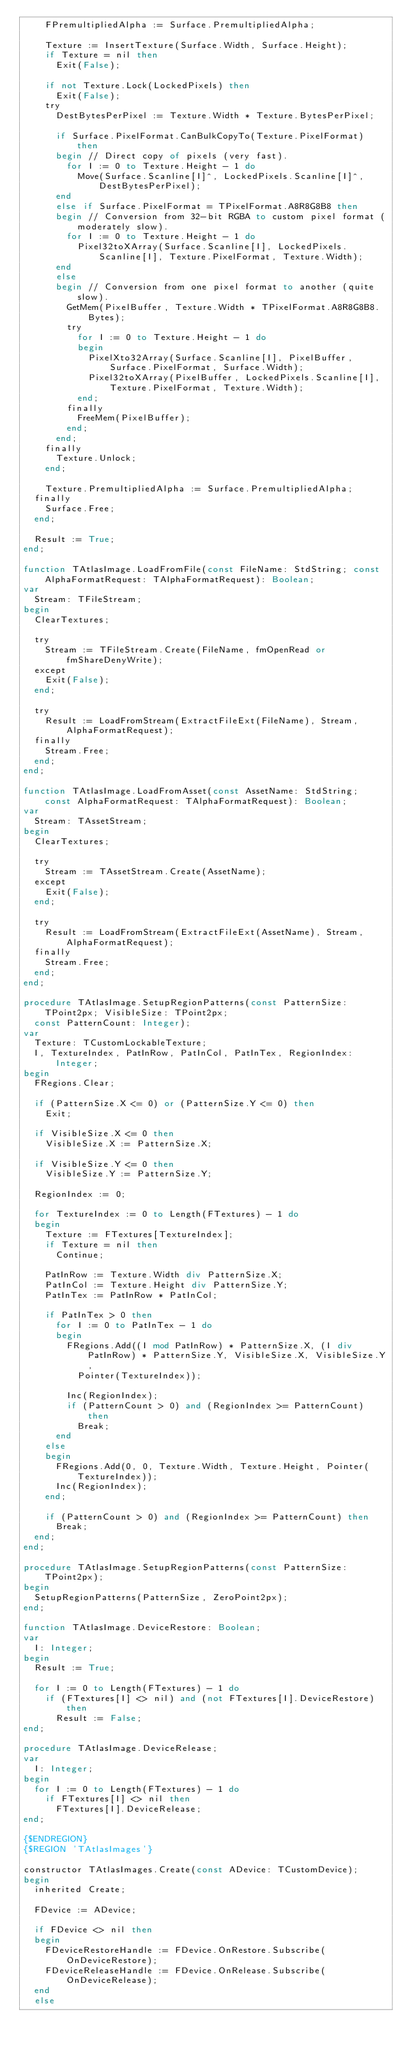Convert code to text. <code><loc_0><loc_0><loc_500><loc_500><_Pascal_>    FPremultipliedAlpha := Surface.PremultipliedAlpha;

    Texture := InsertTexture(Surface.Width, Surface.Height);
    if Texture = nil then
      Exit(False);

    if not Texture.Lock(LockedPixels) then
      Exit(False);
    try
      DestBytesPerPixel := Texture.Width * Texture.BytesPerPixel;

      if Surface.PixelFormat.CanBulkCopyTo(Texture.PixelFormat) then
      begin // Direct copy of pixels (very fast).
        for I := 0 to Texture.Height - 1 do
          Move(Surface.Scanline[I]^, LockedPixels.Scanline[I]^, DestBytesPerPixel);
      end
      else if Surface.PixelFormat = TPixelFormat.A8R8G8B8 then
      begin // Conversion from 32-bit RGBA to custom pixel format (moderately slow).
        for I := 0 to Texture.Height - 1 do
          Pixel32toXArray(Surface.Scanline[I], LockedPixels.Scanline[I], Texture.PixelFormat, Texture.Width);
      end
      else
      begin // Conversion from one pixel format to another (quite slow).
        GetMem(PixelBuffer, Texture.Width * TPixelFormat.A8R8G8B8.Bytes);
        try
          for I := 0 to Texture.Height - 1 do
          begin
            PixelXto32Array(Surface.Scanline[I], PixelBuffer, Surface.PixelFormat, Surface.Width);
            Pixel32toXArray(PixelBuffer, LockedPixels.Scanline[I], Texture.PixelFormat, Texture.Width);
          end;
        finally
          FreeMem(PixelBuffer);
        end;
      end;
    finally
      Texture.Unlock;
    end;

    Texture.PremultipliedAlpha := Surface.PremultipliedAlpha;
  finally
    Surface.Free;
  end;

  Result := True;
end;

function TAtlasImage.LoadFromFile(const FileName: StdString; const AlphaFormatRequest: TAlphaFormatRequest): Boolean;
var
  Stream: TFileStream;
begin
  ClearTextures;

  try
    Stream := TFileStream.Create(FileName, fmOpenRead or fmShareDenyWrite);
  except
    Exit(False);
  end;

  try
    Result := LoadFromStream(ExtractFileExt(FileName), Stream, AlphaFormatRequest);
  finally
    Stream.Free;
  end;
end;

function TAtlasImage.LoadFromAsset(const AssetName: StdString; const AlphaFormatRequest: TAlphaFormatRequest): Boolean;
var
  Stream: TAssetStream;
begin
  ClearTextures;

  try
    Stream := TAssetStream.Create(AssetName);
  except
    Exit(False);
  end;

  try
    Result := LoadFromStream(ExtractFileExt(AssetName), Stream, AlphaFormatRequest);
  finally
    Stream.Free;
  end;
end;

procedure TAtlasImage.SetupRegionPatterns(const PatternSize: TPoint2px; VisibleSize: TPoint2px;
  const PatternCount: Integer);
var
  Texture: TCustomLockableTexture;
  I, TextureIndex, PatInRow, PatInCol, PatInTex, RegionIndex: Integer;
begin
  FRegions.Clear;

  if (PatternSize.X <= 0) or (PatternSize.Y <= 0) then
    Exit;

  if VisibleSize.X <= 0 then
    VisibleSize.X := PatternSize.X;

  if VisibleSize.Y <= 0 then
    VisibleSize.Y := PatternSize.Y;

  RegionIndex := 0;

  for TextureIndex := 0 to Length(FTextures) - 1 do
  begin
    Texture := FTextures[TextureIndex];
    if Texture = nil then
      Continue;

    PatInRow := Texture.Width div PatternSize.X;
    PatInCol := Texture.Height div PatternSize.Y;
    PatInTex := PatInRow * PatInCol;

    if PatInTex > 0 then
      for I := 0 to PatInTex - 1 do
      begin
        FRegions.Add((I mod PatInRow) * PatternSize.X, (I div PatInRow) * PatternSize.Y, VisibleSize.X, VisibleSize.Y,
          Pointer(TextureIndex));

        Inc(RegionIndex);
        if (PatternCount > 0) and (RegionIndex >= PatternCount) then
          Break;
      end
    else
    begin
      FRegions.Add(0, 0, Texture.Width, Texture.Height, Pointer(TextureIndex));
      Inc(RegionIndex);
    end;

    if (PatternCount > 0) and (RegionIndex >= PatternCount) then
      Break;
  end;
end;

procedure TAtlasImage.SetupRegionPatterns(const PatternSize: TPoint2px);
begin
  SetupRegionPatterns(PatternSize, ZeroPoint2px);
end;

function TAtlasImage.DeviceRestore: Boolean;
var
  I: Integer;
begin
  Result := True;

  for I := 0 to Length(FTextures) - 1 do
    if (FTextures[I] <> nil) and (not FTextures[I].DeviceRestore) then
      Result := False;
end;

procedure TAtlasImage.DeviceRelease;
var
  I: Integer;
begin
  for I := 0 to Length(FTextures) - 1 do
    if FTextures[I] <> nil then
      FTextures[I].DeviceRelease;
end;

{$ENDREGION}
{$REGION 'TAtlasImages'}

constructor TAtlasImages.Create(const ADevice: TCustomDevice);
begin
  inherited Create;

  FDevice := ADevice;

  if FDevice <> nil then
  begin
    FDeviceRestoreHandle := FDevice.OnRestore.Subscribe(OnDeviceRestore);
    FDeviceReleaseHandle := FDevice.OnRelease.Subscribe(OnDeviceRelease);
  end
  else</code> 